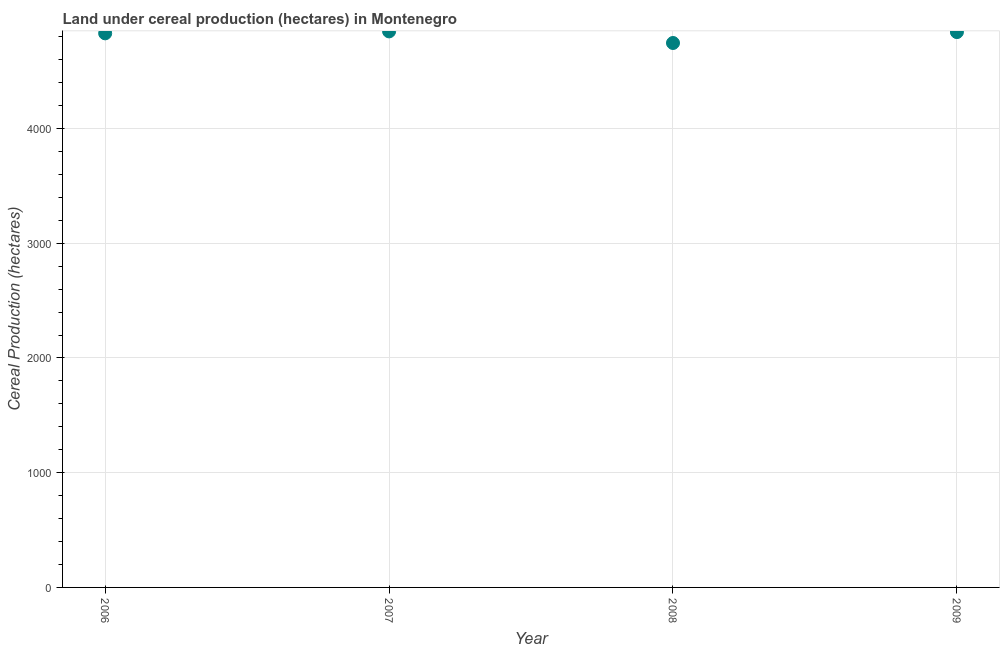What is the land under cereal production in 2007?
Offer a terse response. 4847. Across all years, what is the maximum land under cereal production?
Your response must be concise. 4847. Across all years, what is the minimum land under cereal production?
Offer a terse response. 4746. In which year was the land under cereal production minimum?
Ensure brevity in your answer.  2008. What is the sum of the land under cereal production?
Ensure brevity in your answer.  1.93e+04. What is the difference between the land under cereal production in 2008 and 2009?
Offer a very short reply. -95. What is the average land under cereal production per year?
Ensure brevity in your answer.  4816. What is the median land under cereal production?
Keep it short and to the point. 4835.5. Do a majority of the years between 2009 and 2008 (inclusive) have land under cereal production greater than 2000 hectares?
Make the answer very short. No. What is the ratio of the land under cereal production in 2006 to that in 2009?
Keep it short and to the point. 1. Is the difference between the land under cereal production in 2007 and 2008 greater than the difference between any two years?
Your answer should be very brief. Yes. What is the difference between the highest and the second highest land under cereal production?
Your answer should be very brief. 6. What is the difference between the highest and the lowest land under cereal production?
Provide a succinct answer. 101. Does the land under cereal production monotonically increase over the years?
Provide a succinct answer. No. How many dotlines are there?
Make the answer very short. 1. What is the difference between two consecutive major ticks on the Y-axis?
Your response must be concise. 1000. Does the graph contain grids?
Ensure brevity in your answer.  Yes. What is the title of the graph?
Your response must be concise. Land under cereal production (hectares) in Montenegro. What is the label or title of the Y-axis?
Your answer should be very brief. Cereal Production (hectares). What is the Cereal Production (hectares) in 2006?
Keep it short and to the point. 4830. What is the Cereal Production (hectares) in 2007?
Make the answer very short. 4847. What is the Cereal Production (hectares) in 2008?
Provide a succinct answer. 4746. What is the Cereal Production (hectares) in 2009?
Ensure brevity in your answer.  4841. What is the difference between the Cereal Production (hectares) in 2006 and 2008?
Make the answer very short. 84. What is the difference between the Cereal Production (hectares) in 2006 and 2009?
Offer a terse response. -11. What is the difference between the Cereal Production (hectares) in 2007 and 2008?
Make the answer very short. 101. What is the difference between the Cereal Production (hectares) in 2008 and 2009?
Make the answer very short. -95. What is the ratio of the Cereal Production (hectares) in 2007 to that in 2009?
Offer a terse response. 1. 